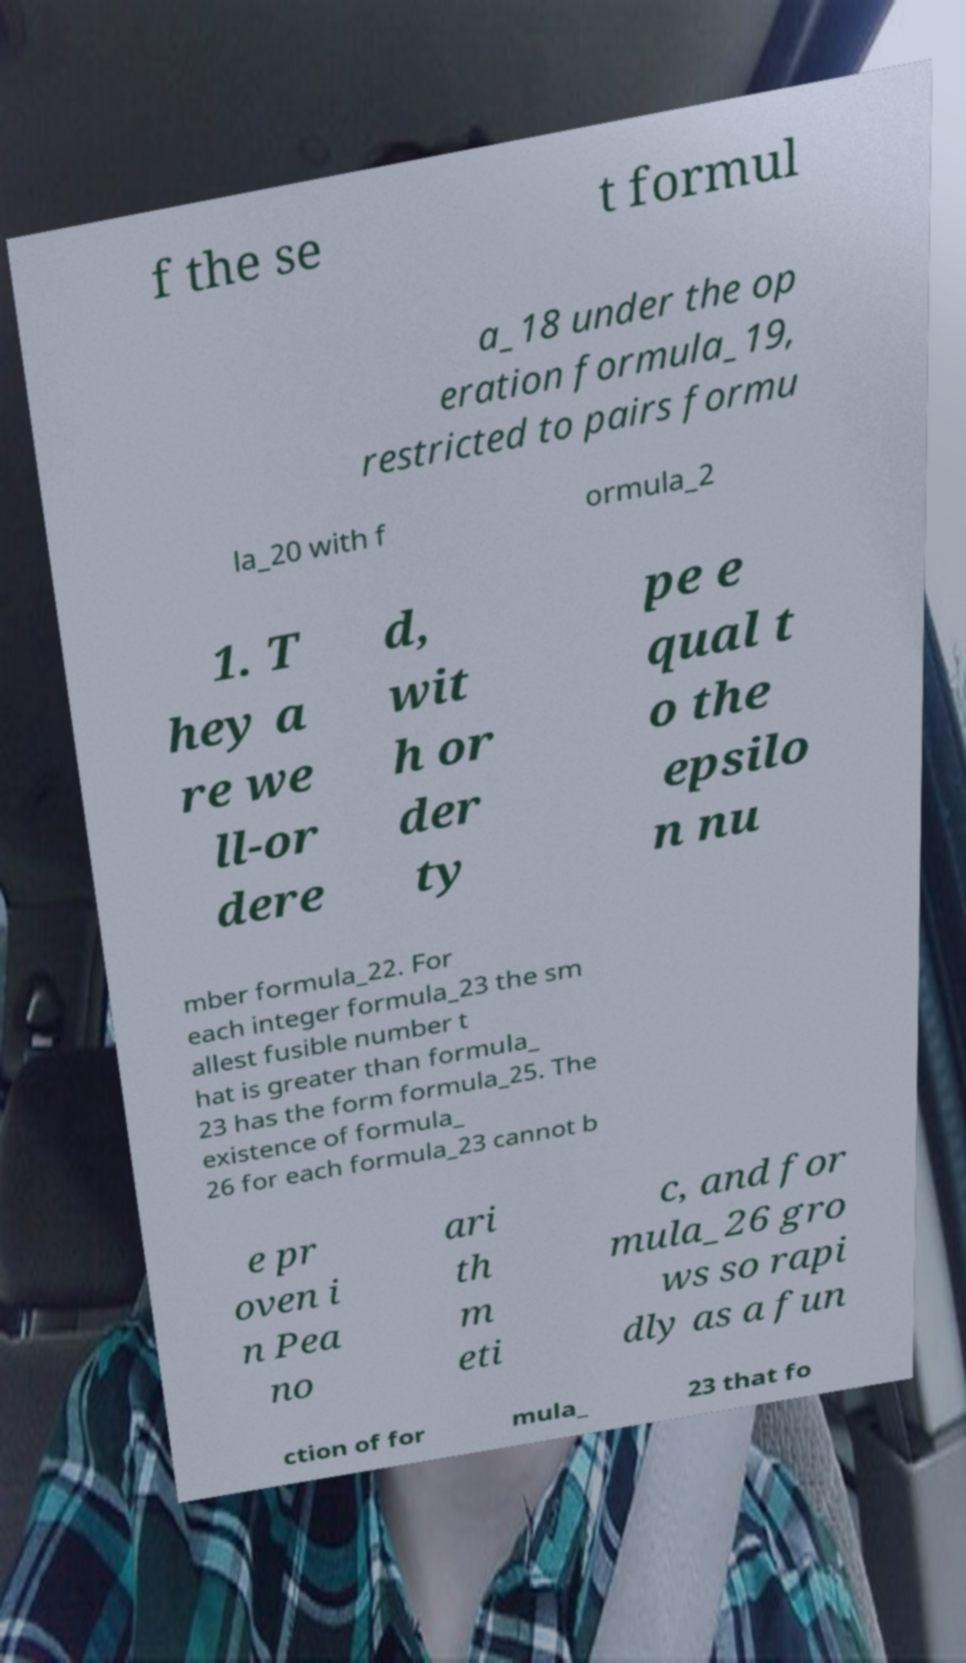Can you accurately transcribe the text from the provided image for me? f the se t formul a_18 under the op eration formula_19, restricted to pairs formu la_20 with f ormula_2 1. T hey a re we ll-or dere d, wit h or der ty pe e qual t o the epsilo n nu mber formula_22. For each integer formula_23 the sm allest fusible number t hat is greater than formula_ 23 has the form formula_25. The existence of formula_ 26 for each formula_23 cannot b e pr oven i n Pea no ari th m eti c, and for mula_26 gro ws so rapi dly as a fun ction of for mula_ 23 that fo 